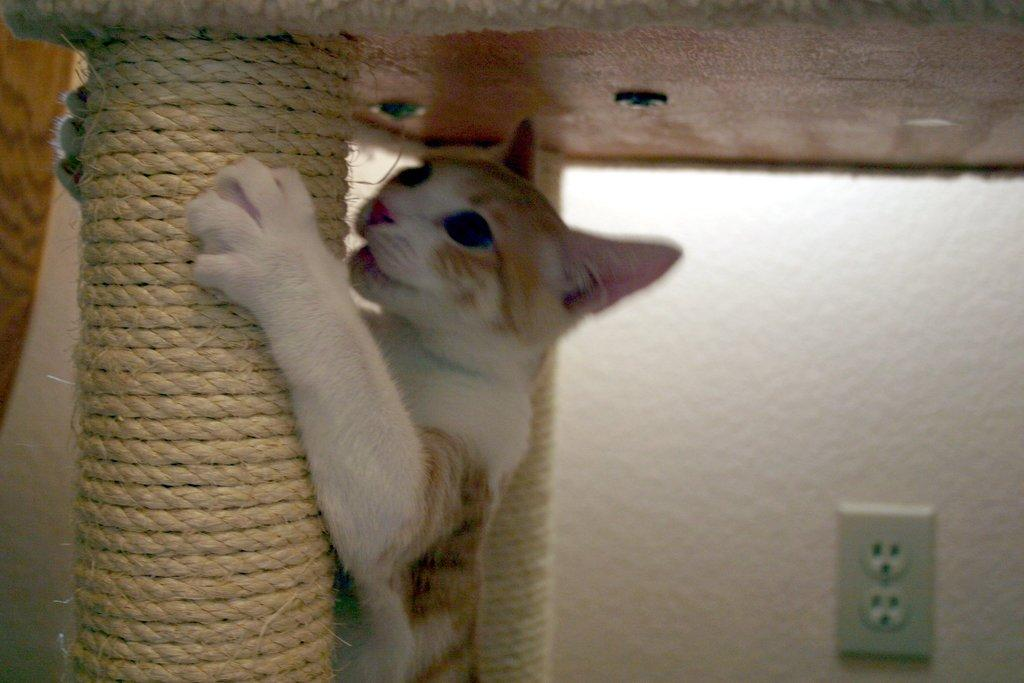What animal can be seen in the image? There is a cat in the image. What is the cat holding in its mouth? The cat is holding an object tied with a rope. What can be seen in the background of the image? There is a wall in the background of the image. What feature is present on the wall? There is a socket on the wall. What does the object held by the cat resemble? The object held by the cat resembles a table. How many rings can be seen on the cat's tail in the image? There are no rings visible on the cat's tail in the image. What type of seed is being planted by the cat in the image? There is no seed or planting activity depicted in the image; the cat is holding an object tied with a rope. 